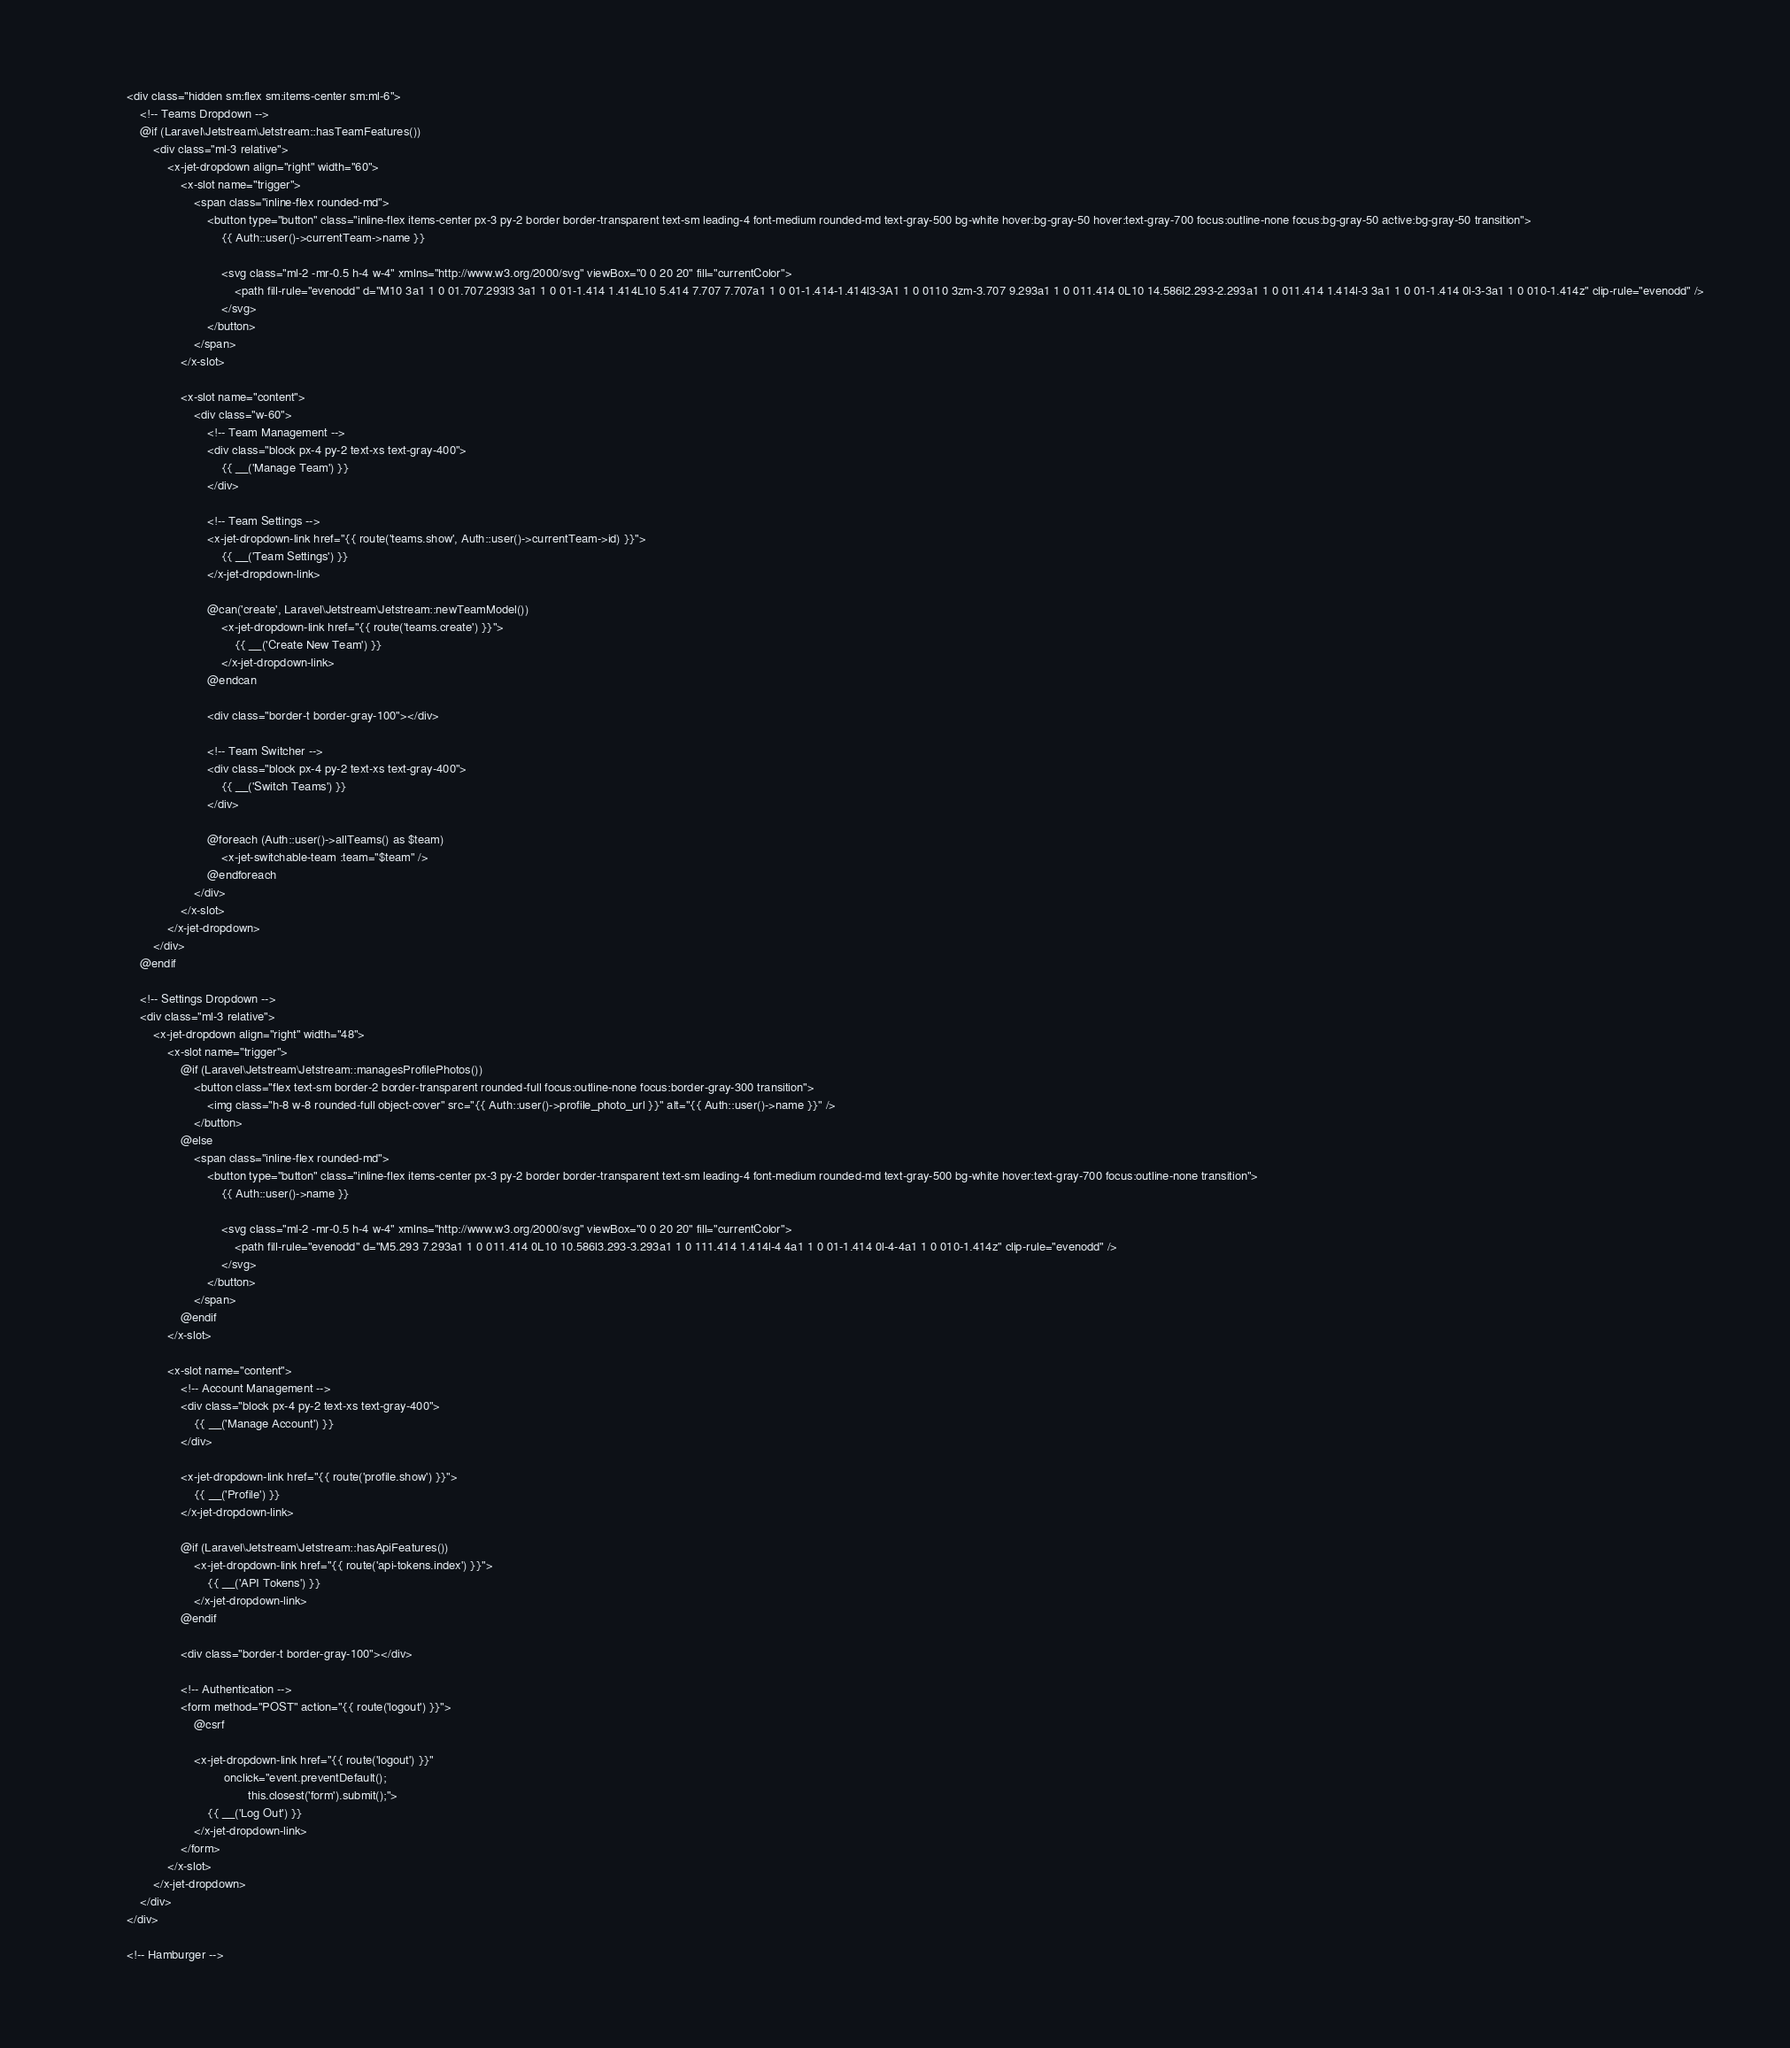<code> <loc_0><loc_0><loc_500><loc_500><_PHP_>
            <div class="hidden sm:flex sm:items-center sm:ml-6">
                <!-- Teams Dropdown -->
                @if (Laravel\Jetstream\Jetstream::hasTeamFeatures())
                    <div class="ml-3 relative">
                        <x-jet-dropdown align="right" width="60">
                            <x-slot name="trigger">
                                <span class="inline-flex rounded-md">
                                    <button type="button" class="inline-flex items-center px-3 py-2 border border-transparent text-sm leading-4 font-medium rounded-md text-gray-500 bg-white hover:bg-gray-50 hover:text-gray-700 focus:outline-none focus:bg-gray-50 active:bg-gray-50 transition">
                                        {{ Auth::user()->currentTeam->name }}

                                        <svg class="ml-2 -mr-0.5 h-4 w-4" xmlns="http://www.w3.org/2000/svg" viewBox="0 0 20 20" fill="currentColor">
                                            <path fill-rule="evenodd" d="M10 3a1 1 0 01.707.293l3 3a1 1 0 01-1.414 1.414L10 5.414 7.707 7.707a1 1 0 01-1.414-1.414l3-3A1 1 0 0110 3zm-3.707 9.293a1 1 0 011.414 0L10 14.586l2.293-2.293a1 1 0 011.414 1.414l-3 3a1 1 0 01-1.414 0l-3-3a1 1 0 010-1.414z" clip-rule="evenodd" />
                                        </svg>
                                    </button>
                                </span>
                            </x-slot>

                            <x-slot name="content">
                                <div class="w-60">
                                    <!-- Team Management -->
                                    <div class="block px-4 py-2 text-xs text-gray-400">
                                        {{ __('Manage Team') }}
                                    </div>

                                    <!-- Team Settings -->
                                    <x-jet-dropdown-link href="{{ route('teams.show', Auth::user()->currentTeam->id) }}">
                                        {{ __('Team Settings') }}
                                    </x-jet-dropdown-link>

                                    @can('create', Laravel\Jetstream\Jetstream::newTeamModel())
                                        <x-jet-dropdown-link href="{{ route('teams.create') }}">
                                            {{ __('Create New Team') }}
                                        </x-jet-dropdown-link>
                                    @endcan

                                    <div class="border-t border-gray-100"></div>

                                    <!-- Team Switcher -->
                                    <div class="block px-4 py-2 text-xs text-gray-400">
                                        {{ __('Switch Teams') }}
                                    </div>

                                    @foreach (Auth::user()->allTeams() as $team)
                                        <x-jet-switchable-team :team="$team" />
                                    @endforeach
                                </div>
                            </x-slot>
                        </x-jet-dropdown>
                    </div>
                @endif

                <!-- Settings Dropdown -->
                <div class="ml-3 relative">
                    <x-jet-dropdown align="right" width="48">
                        <x-slot name="trigger">
                            @if (Laravel\Jetstream\Jetstream::managesProfilePhotos())
                                <button class="flex text-sm border-2 border-transparent rounded-full focus:outline-none focus:border-gray-300 transition">
                                    <img class="h-8 w-8 rounded-full object-cover" src="{{ Auth::user()->profile_photo_url }}" alt="{{ Auth::user()->name }}" />
                                </button>
                            @else
                                <span class="inline-flex rounded-md">
                                    <button type="button" class="inline-flex items-center px-3 py-2 border border-transparent text-sm leading-4 font-medium rounded-md text-gray-500 bg-white hover:text-gray-700 focus:outline-none transition">
                                        {{ Auth::user()->name }}

                                        <svg class="ml-2 -mr-0.5 h-4 w-4" xmlns="http://www.w3.org/2000/svg" viewBox="0 0 20 20" fill="currentColor">
                                            <path fill-rule="evenodd" d="M5.293 7.293a1 1 0 011.414 0L10 10.586l3.293-3.293a1 1 0 111.414 1.414l-4 4a1 1 0 01-1.414 0l-4-4a1 1 0 010-1.414z" clip-rule="evenodd" />
                                        </svg>
                                    </button>
                                </span>
                            @endif
                        </x-slot>

                        <x-slot name="content">
                            <!-- Account Management -->
                            <div class="block px-4 py-2 text-xs text-gray-400">
                                {{ __('Manage Account') }}
                            </div>

                            <x-jet-dropdown-link href="{{ route('profile.show') }}">
                                {{ __('Profile') }}
                            </x-jet-dropdown-link>

                            @if (Laravel\Jetstream\Jetstream::hasApiFeatures())
                                <x-jet-dropdown-link href="{{ route('api-tokens.index') }}">
                                    {{ __('API Tokens') }}
                                </x-jet-dropdown-link>
                            @endif

                            <div class="border-t border-gray-100"></div>

                            <!-- Authentication -->
                            <form method="POST" action="{{ route('logout') }}">
                                @csrf

                                <x-jet-dropdown-link href="{{ route('logout') }}"
                                         onclick="event.preventDefault();
                                                this.closest('form').submit();">
                                    {{ __('Log Out') }}
                                </x-jet-dropdown-link>
                            </form>
                        </x-slot>
                    </x-jet-dropdown>
                </div>
            </div>

            <!-- Hamburger --></code> 